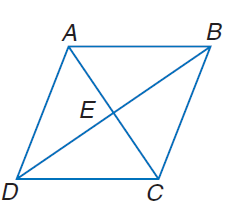Answer the mathemtical geometry problem and directly provide the correct option letter.
Question: In rhombus A B C D, A B = 2 x + 3 and B C = 5 x. Find x.
Choices: A: 1 B: 2 C: 4 D: 5 A 